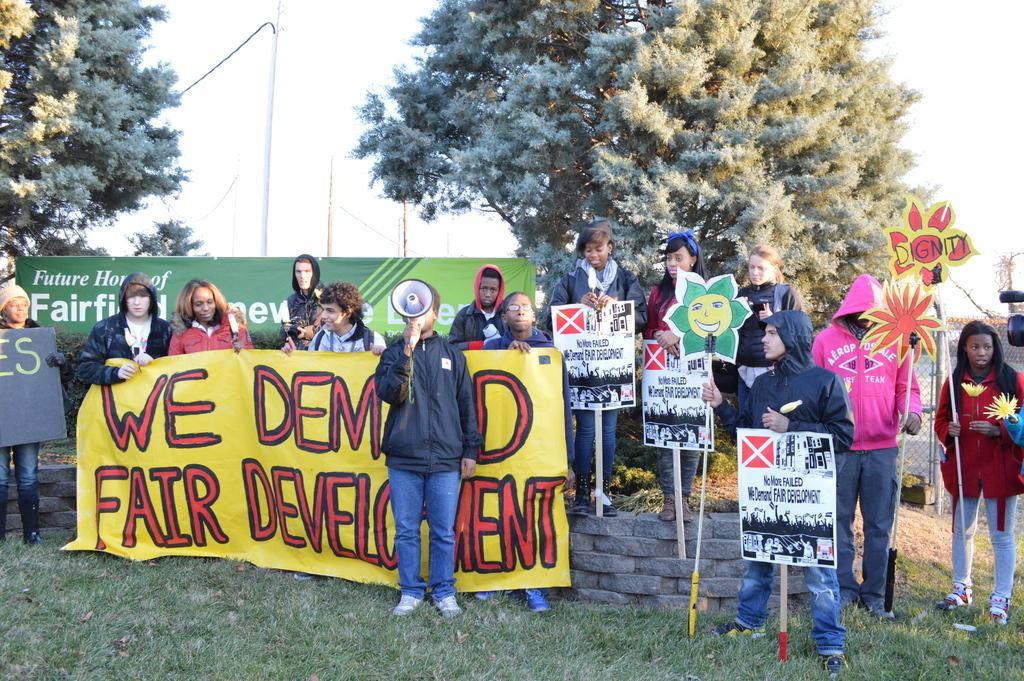How would you summarize this image in a sentence or two? In this image there are people holding the banners and placards. At the bottom of the image there is grass on the surface. In the background of the image there are trees, poles and sky 